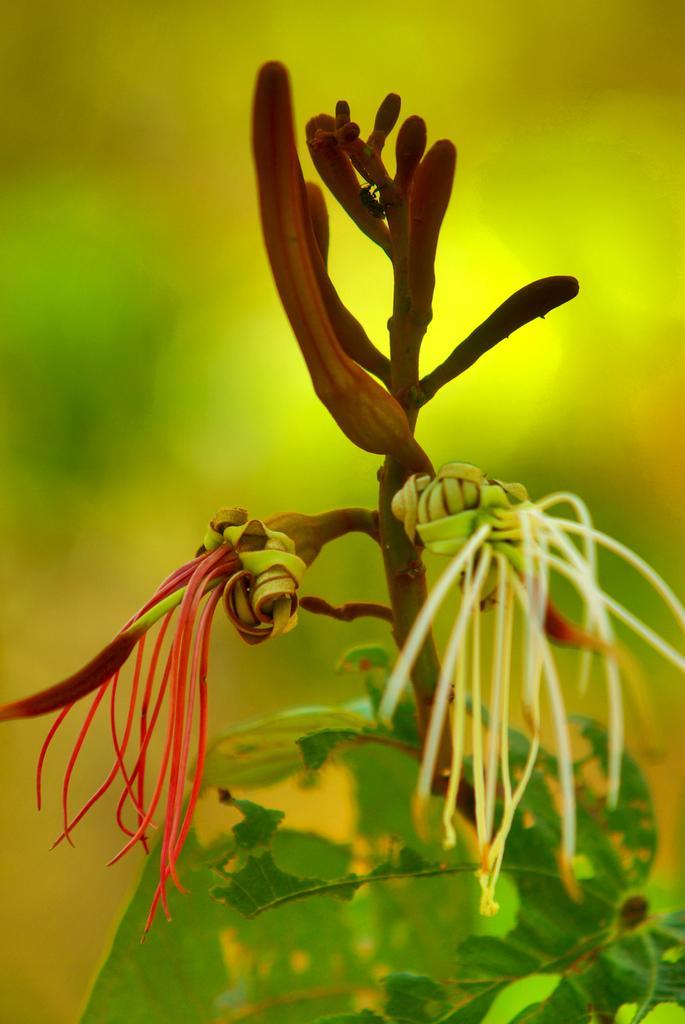How would you summarize this image in a sentence or two? In this image we can see a plant with buds and in the background the image is blur. 